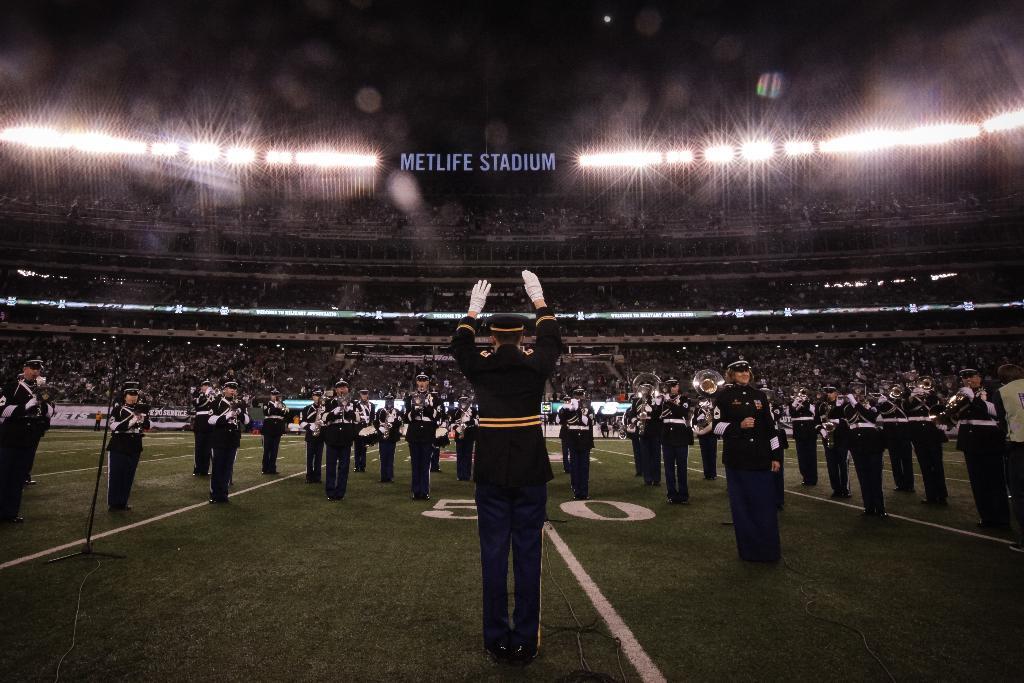How would you summarize this image in a sentence or two? In this image we can see people standing and playing musical instruments. They are wearing uniforms. In the background there is crowd sitting. At the top there are lights and we can see a board. 